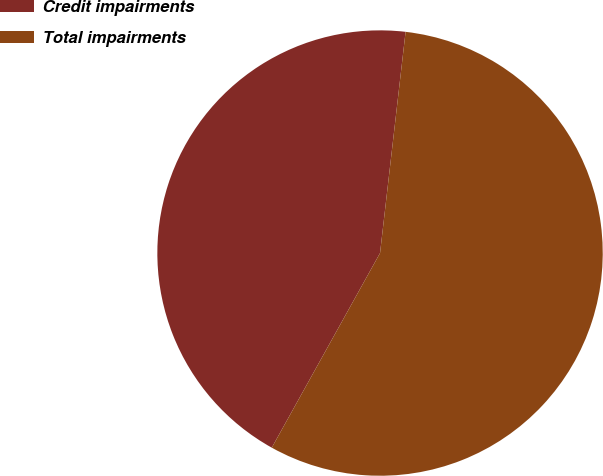Convert chart to OTSL. <chart><loc_0><loc_0><loc_500><loc_500><pie_chart><fcel>Credit impairments<fcel>Total impairments<nl><fcel>43.75%<fcel>56.25%<nl></chart> 